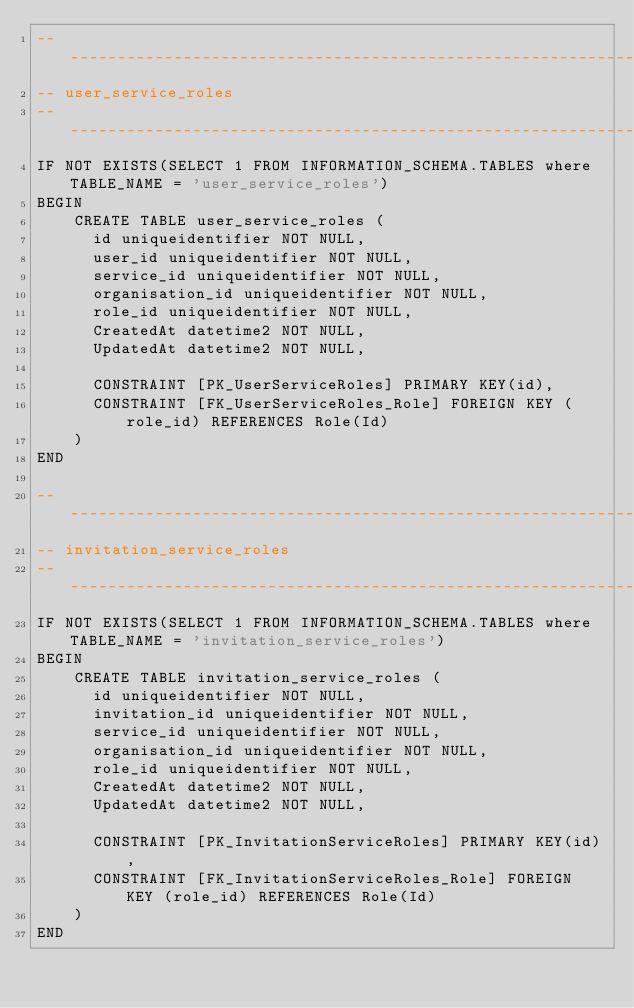Convert code to text. <code><loc_0><loc_0><loc_500><loc_500><_SQL_>--------------------------------------------------------------------------------------------------
-- user_service_roles
--------------------------------------------------------------------------------------------------
IF NOT EXISTS(SELECT 1 FROM INFORMATION_SCHEMA.TABLES where TABLE_NAME = 'user_service_roles')
BEGIN
    CREATE TABLE user_service_roles (
      id uniqueidentifier NOT NULL,
      user_id uniqueidentifier NOT NULL,
      service_id uniqueidentifier NOT NULL,
      organisation_id uniqueidentifier NOT NULL,
      role_id uniqueidentifier NOT NULL,
      CreatedAt datetime2 NOT NULL,
      UpdatedAt datetime2 NOT NULL,

      CONSTRAINT [PK_UserServiceRoles] PRIMARY KEY(id),
      CONSTRAINT [FK_UserServiceRoles_Role] FOREIGN KEY (role_id) REFERENCES Role(Id)
    )
END

--------------------------------------------------------------------------------------------------
-- invitation_service_roles
--------------------------------------------------------------------------------------------------
IF NOT EXISTS(SELECT 1 FROM INFORMATION_SCHEMA.TABLES where TABLE_NAME = 'invitation_service_roles')
BEGIN
    CREATE TABLE invitation_service_roles (
      id uniqueidentifier NOT NULL,
      invitation_id uniqueidentifier NOT NULL,
      service_id uniqueidentifier NOT NULL,
      organisation_id uniqueidentifier NOT NULL,
      role_id uniqueidentifier NOT NULL,
      CreatedAt datetime2 NOT NULL,
      UpdatedAt datetime2 NOT NULL,

      CONSTRAINT [PK_InvitationServiceRoles] PRIMARY KEY(id),
      CONSTRAINT [FK_InvitationServiceRoles_Role] FOREIGN KEY (role_id) REFERENCES Role(Id)
    )
END</code> 